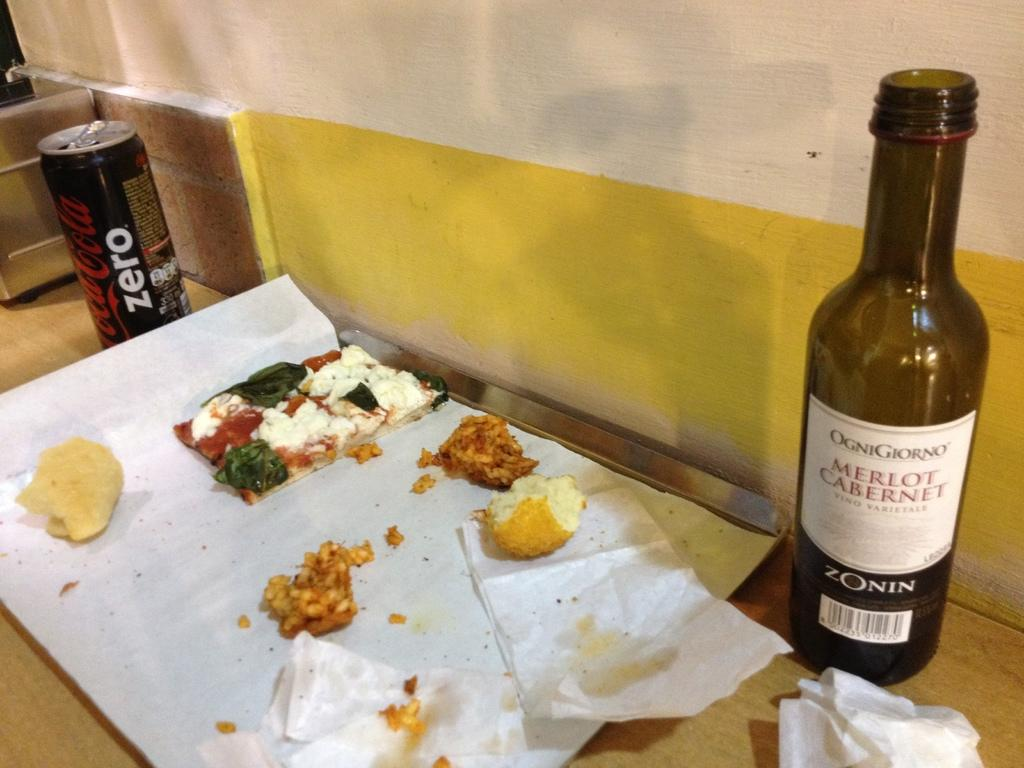<image>
Present a compact description of the photo's key features. A bottle of "MERLOT CABERNET" is next to a tray of food. 